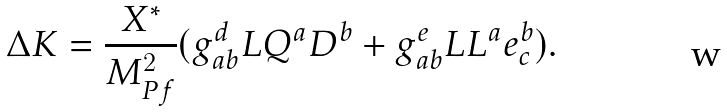Convert formula to latex. <formula><loc_0><loc_0><loc_500><loc_500>\Delta K = { \frac { X ^ { * } } { M _ { P f } ^ { 2 } } } ( g _ { a b } ^ { d } L Q ^ { a } D ^ { b } + g _ { a b } ^ { e } L L ^ { a } e _ { c } ^ { b } ) .</formula> 